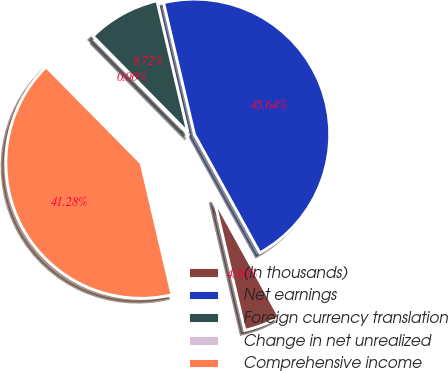Convert chart. <chart><loc_0><loc_0><loc_500><loc_500><pie_chart><fcel>(In thousands)<fcel>Net earnings<fcel>Foreign currency translation<fcel>Change in net unrealized<fcel>Comprehensive income<nl><fcel>4.36%<fcel>45.64%<fcel>8.72%<fcel>0.0%<fcel>41.28%<nl></chart> 